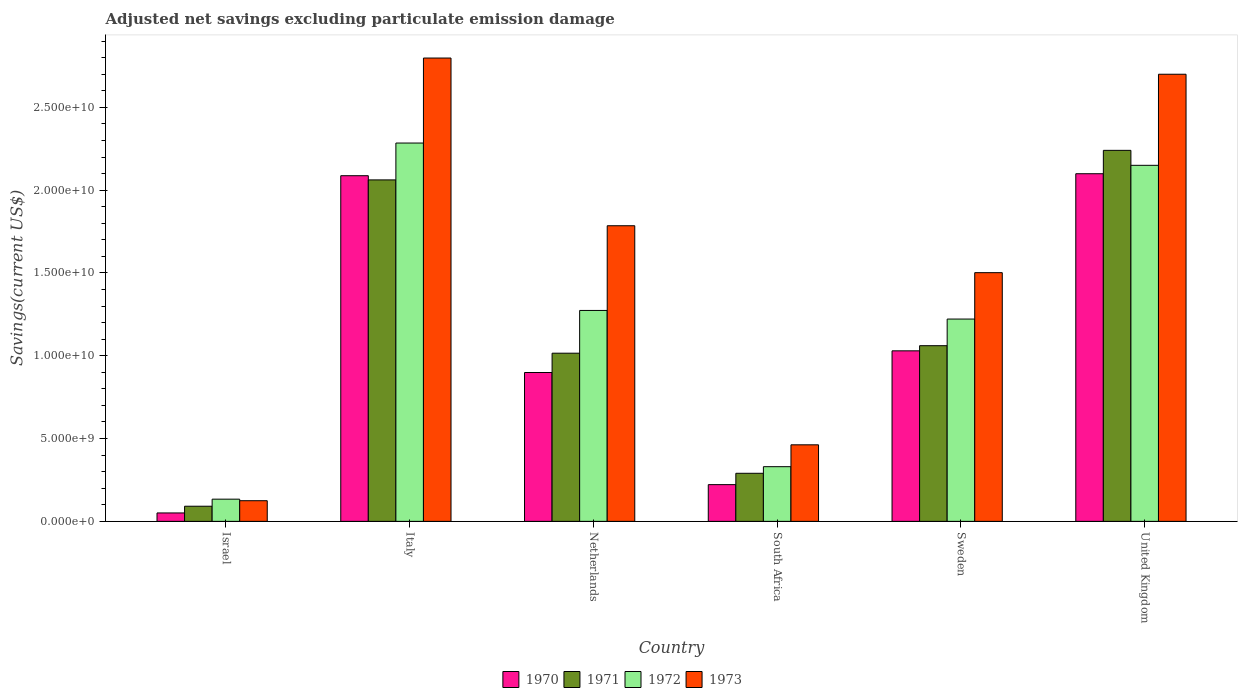How many groups of bars are there?
Offer a very short reply. 6. Are the number of bars per tick equal to the number of legend labels?
Give a very brief answer. Yes. How many bars are there on the 6th tick from the left?
Your answer should be compact. 4. How many bars are there on the 1st tick from the right?
Keep it short and to the point. 4. What is the label of the 3rd group of bars from the left?
Make the answer very short. Netherlands. What is the adjusted net savings in 1970 in Israel?
Give a very brief answer. 5.08e+08. Across all countries, what is the maximum adjusted net savings in 1973?
Provide a succinct answer. 2.80e+1. Across all countries, what is the minimum adjusted net savings in 1970?
Make the answer very short. 5.08e+08. In which country was the adjusted net savings in 1970 maximum?
Your response must be concise. United Kingdom. What is the total adjusted net savings in 1973 in the graph?
Your answer should be compact. 9.37e+1. What is the difference between the adjusted net savings in 1972 in Italy and that in Netherlands?
Give a very brief answer. 1.01e+1. What is the difference between the adjusted net savings in 1970 in United Kingdom and the adjusted net savings in 1972 in Italy?
Your response must be concise. -1.85e+09. What is the average adjusted net savings in 1970 per country?
Your answer should be compact. 1.06e+1. What is the difference between the adjusted net savings of/in 1971 and adjusted net savings of/in 1970 in Sweden?
Provide a succinct answer. 3.10e+08. What is the ratio of the adjusted net savings in 1970 in Netherlands to that in Sweden?
Your answer should be very brief. 0.87. Is the adjusted net savings in 1973 in Israel less than that in South Africa?
Your response must be concise. Yes. What is the difference between the highest and the second highest adjusted net savings in 1971?
Your response must be concise. -1.18e+1. What is the difference between the highest and the lowest adjusted net savings in 1972?
Your answer should be compact. 2.15e+1. In how many countries, is the adjusted net savings in 1972 greater than the average adjusted net savings in 1972 taken over all countries?
Ensure brevity in your answer.  3. What does the 4th bar from the right in Italy represents?
Offer a terse response. 1970. Is it the case that in every country, the sum of the adjusted net savings in 1970 and adjusted net savings in 1972 is greater than the adjusted net savings in 1971?
Your answer should be compact. Yes. How many bars are there?
Keep it short and to the point. 24. Does the graph contain grids?
Keep it short and to the point. No. Where does the legend appear in the graph?
Make the answer very short. Bottom center. What is the title of the graph?
Your response must be concise. Adjusted net savings excluding particulate emission damage. Does "1994" appear as one of the legend labels in the graph?
Ensure brevity in your answer.  No. What is the label or title of the Y-axis?
Your answer should be very brief. Savings(current US$). What is the Savings(current US$) of 1970 in Israel?
Offer a terse response. 5.08e+08. What is the Savings(current US$) of 1971 in Israel?
Offer a very short reply. 9.14e+08. What is the Savings(current US$) in 1972 in Israel?
Offer a terse response. 1.34e+09. What is the Savings(current US$) in 1973 in Israel?
Provide a short and direct response. 1.25e+09. What is the Savings(current US$) in 1970 in Italy?
Your response must be concise. 2.09e+1. What is the Savings(current US$) of 1971 in Italy?
Your answer should be compact. 2.06e+1. What is the Savings(current US$) of 1972 in Italy?
Offer a terse response. 2.28e+1. What is the Savings(current US$) of 1973 in Italy?
Your response must be concise. 2.80e+1. What is the Savings(current US$) in 1970 in Netherlands?
Your answer should be compact. 8.99e+09. What is the Savings(current US$) in 1971 in Netherlands?
Give a very brief answer. 1.02e+1. What is the Savings(current US$) of 1972 in Netherlands?
Keep it short and to the point. 1.27e+1. What is the Savings(current US$) in 1973 in Netherlands?
Provide a short and direct response. 1.79e+1. What is the Savings(current US$) in 1970 in South Africa?
Your response must be concise. 2.22e+09. What is the Savings(current US$) of 1971 in South Africa?
Make the answer very short. 2.90e+09. What is the Savings(current US$) in 1972 in South Africa?
Give a very brief answer. 3.30e+09. What is the Savings(current US$) in 1973 in South Africa?
Your answer should be compact. 4.62e+09. What is the Savings(current US$) of 1970 in Sweden?
Give a very brief answer. 1.03e+1. What is the Savings(current US$) of 1971 in Sweden?
Provide a succinct answer. 1.06e+1. What is the Savings(current US$) of 1972 in Sweden?
Ensure brevity in your answer.  1.22e+1. What is the Savings(current US$) of 1973 in Sweden?
Offer a very short reply. 1.50e+1. What is the Savings(current US$) in 1970 in United Kingdom?
Provide a succinct answer. 2.10e+1. What is the Savings(current US$) in 1971 in United Kingdom?
Your response must be concise. 2.24e+1. What is the Savings(current US$) in 1972 in United Kingdom?
Give a very brief answer. 2.15e+1. What is the Savings(current US$) of 1973 in United Kingdom?
Your answer should be compact. 2.70e+1. Across all countries, what is the maximum Savings(current US$) of 1970?
Offer a terse response. 2.10e+1. Across all countries, what is the maximum Savings(current US$) in 1971?
Keep it short and to the point. 2.24e+1. Across all countries, what is the maximum Savings(current US$) in 1972?
Make the answer very short. 2.28e+1. Across all countries, what is the maximum Savings(current US$) of 1973?
Provide a short and direct response. 2.80e+1. Across all countries, what is the minimum Savings(current US$) of 1970?
Offer a very short reply. 5.08e+08. Across all countries, what is the minimum Savings(current US$) of 1971?
Give a very brief answer. 9.14e+08. Across all countries, what is the minimum Savings(current US$) in 1972?
Make the answer very short. 1.34e+09. Across all countries, what is the minimum Savings(current US$) in 1973?
Your answer should be very brief. 1.25e+09. What is the total Savings(current US$) of 1970 in the graph?
Your answer should be compact. 6.39e+1. What is the total Savings(current US$) in 1971 in the graph?
Offer a terse response. 6.76e+1. What is the total Savings(current US$) in 1972 in the graph?
Your answer should be compact. 7.39e+1. What is the total Savings(current US$) in 1973 in the graph?
Make the answer very short. 9.37e+1. What is the difference between the Savings(current US$) of 1970 in Israel and that in Italy?
Keep it short and to the point. -2.04e+1. What is the difference between the Savings(current US$) in 1971 in Israel and that in Italy?
Your answer should be very brief. -1.97e+1. What is the difference between the Savings(current US$) of 1972 in Israel and that in Italy?
Make the answer very short. -2.15e+1. What is the difference between the Savings(current US$) in 1973 in Israel and that in Italy?
Provide a succinct answer. -2.67e+1. What is the difference between the Savings(current US$) in 1970 in Israel and that in Netherlands?
Provide a succinct answer. -8.48e+09. What is the difference between the Savings(current US$) in 1971 in Israel and that in Netherlands?
Your answer should be very brief. -9.24e+09. What is the difference between the Savings(current US$) of 1972 in Israel and that in Netherlands?
Offer a very short reply. -1.14e+1. What is the difference between the Savings(current US$) in 1973 in Israel and that in Netherlands?
Make the answer very short. -1.66e+1. What is the difference between the Savings(current US$) of 1970 in Israel and that in South Africa?
Your answer should be compact. -1.71e+09. What is the difference between the Savings(current US$) of 1971 in Israel and that in South Africa?
Make the answer very short. -1.99e+09. What is the difference between the Savings(current US$) of 1972 in Israel and that in South Africa?
Offer a terse response. -1.96e+09. What is the difference between the Savings(current US$) of 1973 in Israel and that in South Africa?
Keep it short and to the point. -3.38e+09. What is the difference between the Savings(current US$) of 1970 in Israel and that in Sweden?
Your answer should be very brief. -9.79e+09. What is the difference between the Savings(current US$) of 1971 in Israel and that in Sweden?
Your response must be concise. -9.69e+09. What is the difference between the Savings(current US$) of 1972 in Israel and that in Sweden?
Give a very brief answer. -1.09e+1. What is the difference between the Savings(current US$) of 1973 in Israel and that in Sweden?
Make the answer very short. -1.38e+1. What is the difference between the Savings(current US$) in 1970 in Israel and that in United Kingdom?
Provide a succinct answer. -2.05e+1. What is the difference between the Savings(current US$) of 1971 in Israel and that in United Kingdom?
Offer a very short reply. -2.15e+1. What is the difference between the Savings(current US$) in 1972 in Israel and that in United Kingdom?
Make the answer very short. -2.02e+1. What is the difference between the Savings(current US$) in 1973 in Israel and that in United Kingdom?
Offer a very short reply. -2.58e+1. What is the difference between the Savings(current US$) in 1970 in Italy and that in Netherlands?
Provide a short and direct response. 1.19e+1. What is the difference between the Savings(current US$) of 1971 in Italy and that in Netherlands?
Ensure brevity in your answer.  1.05e+1. What is the difference between the Savings(current US$) of 1972 in Italy and that in Netherlands?
Offer a terse response. 1.01e+1. What is the difference between the Savings(current US$) in 1973 in Italy and that in Netherlands?
Offer a terse response. 1.01e+1. What is the difference between the Savings(current US$) of 1970 in Italy and that in South Africa?
Your answer should be very brief. 1.87e+1. What is the difference between the Savings(current US$) in 1971 in Italy and that in South Africa?
Offer a very short reply. 1.77e+1. What is the difference between the Savings(current US$) in 1972 in Italy and that in South Africa?
Provide a succinct answer. 1.95e+1. What is the difference between the Savings(current US$) in 1973 in Italy and that in South Africa?
Provide a short and direct response. 2.34e+1. What is the difference between the Savings(current US$) of 1970 in Italy and that in Sweden?
Ensure brevity in your answer.  1.06e+1. What is the difference between the Savings(current US$) in 1971 in Italy and that in Sweden?
Your answer should be compact. 1.00e+1. What is the difference between the Savings(current US$) in 1972 in Italy and that in Sweden?
Your answer should be very brief. 1.06e+1. What is the difference between the Savings(current US$) of 1973 in Italy and that in Sweden?
Your answer should be compact. 1.30e+1. What is the difference between the Savings(current US$) in 1970 in Italy and that in United Kingdom?
Provide a short and direct response. -1.20e+08. What is the difference between the Savings(current US$) of 1971 in Italy and that in United Kingdom?
Give a very brief answer. -1.78e+09. What is the difference between the Savings(current US$) of 1972 in Italy and that in United Kingdom?
Keep it short and to the point. 1.34e+09. What is the difference between the Savings(current US$) in 1973 in Italy and that in United Kingdom?
Offer a very short reply. 9.78e+08. What is the difference between the Savings(current US$) of 1970 in Netherlands and that in South Africa?
Provide a short and direct response. 6.77e+09. What is the difference between the Savings(current US$) of 1971 in Netherlands and that in South Africa?
Your answer should be compact. 7.25e+09. What is the difference between the Savings(current US$) of 1972 in Netherlands and that in South Africa?
Your response must be concise. 9.43e+09. What is the difference between the Savings(current US$) in 1973 in Netherlands and that in South Africa?
Offer a terse response. 1.32e+1. What is the difference between the Savings(current US$) in 1970 in Netherlands and that in Sweden?
Offer a very short reply. -1.31e+09. What is the difference between the Savings(current US$) of 1971 in Netherlands and that in Sweden?
Provide a short and direct response. -4.54e+08. What is the difference between the Savings(current US$) of 1972 in Netherlands and that in Sweden?
Your answer should be very brief. 5.20e+08. What is the difference between the Savings(current US$) in 1973 in Netherlands and that in Sweden?
Make the answer very short. 2.83e+09. What is the difference between the Savings(current US$) in 1970 in Netherlands and that in United Kingdom?
Make the answer very short. -1.20e+1. What is the difference between the Savings(current US$) in 1971 in Netherlands and that in United Kingdom?
Ensure brevity in your answer.  -1.22e+1. What is the difference between the Savings(current US$) in 1972 in Netherlands and that in United Kingdom?
Your response must be concise. -8.76e+09. What is the difference between the Savings(current US$) of 1973 in Netherlands and that in United Kingdom?
Provide a short and direct response. -9.15e+09. What is the difference between the Savings(current US$) of 1970 in South Africa and that in Sweden?
Give a very brief answer. -8.08e+09. What is the difference between the Savings(current US$) in 1971 in South Africa and that in Sweden?
Keep it short and to the point. -7.70e+09. What is the difference between the Savings(current US$) of 1972 in South Africa and that in Sweden?
Your answer should be compact. -8.91e+09. What is the difference between the Savings(current US$) of 1973 in South Africa and that in Sweden?
Your answer should be compact. -1.04e+1. What is the difference between the Savings(current US$) of 1970 in South Africa and that in United Kingdom?
Provide a succinct answer. -1.88e+1. What is the difference between the Savings(current US$) in 1971 in South Africa and that in United Kingdom?
Keep it short and to the point. -1.95e+1. What is the difference between the Savings(current US$) in 1972 in South Africa and that in United Kingdom?
Your answer should be very brief. -1.82e+1. What is the difference between the Savings(current US$) of 1973 in South Africa and that in United Kingdom?
Ensure brevity in your answer.  -2.24e+1. What is the difference between the Savings(current US$) in 1970 in Sweden and that in United Kingdom?
Give a very brief answer. -1.07e+1. What is the difference between the Savings(current US$) in 1971 in Sweden and that in United Kingdom?
Offer a very short reply. -1.18e+1. What is the difference between the Savings(current US$) of 1972 in Sweden and that in United Kingdom?
Make the answer very short. -9.28e+09. What is the difference between the Savings(current US$) of 1973 in Sweden and that in United Kingdom?
Your answer should be very brief. -1.20e+1. What is the difference between the Savings(current US$) of 1970 in Israel and the Savings(current US$) of 1971 in Italy?
Offer a very short reply. -2.01e+1. What is the difference between the Savings(current US$) of 1970 in Israel and the Savings(current US$) of 1972 in Italy?
Your response must be concise. -2.23e+1. What is the difference between the Savings(current US$) in 1970 in Israel and the Savings(current US$) in 1973 in Italy?
Your response must be concise. -2.75e+1. What is the difference between the Savings(current US$) in 1971 in Israel and the Savings(current US$) in 1972 in Italy?
Offer a terse response. -2.19e+1. What is the difference between the Savings(current US$) in 1971 in Israel and the Savings(current US$) in 1973 in Italy?
Your answer should be compact. -2.71e+1. What is the difference between the Savings(current US$) in 1972 in Israel and the Savings(current US$) in 1973 in Italy?
Your response must be concise. -2.66e+1. What is the difference between the Savings(current US$) in 1970 in Israel and the Savings(current US$) in 1971 in Netherlands?
Provide a succinct answer. -9.65e+09. What is the difference between the Savings(current US$) in 1970 in Israel and the Savings(current US$) in 1972 in Netherlands?
Provide a succinct answer. -1.22e+1. What is the difference between the Savings(current US$) in 1970 in Israel and the Savings(current US$) in 1973 in Netherlands?
Your answer should be very brief. -1.73e+1. What is the difference between the Savings(current US$) of 1971 in Israel and the Savings(current US$) of 1972 in Netherlands?
Your answer should be very brief. -1.18e+1. What is the difference between the Savings(current US$) of 1971 in Israel and the Savings(current US$) of 1973 in Netherlands?
Keep it short and to the point. -1.69e+1. What is the difference between the Savings(current US$) of 1972 in Israel and the Savings(current US$) of 1973 in Netherlands?
Your answer should be compact. -1.65e+1. What is the difference between the Savings(current US$) of 1970 in Israel and the Savings(current US$) of 1971 in South Africa?
Your answer should be compact. -2.39e+09. What is the difference between the Savings(current US$) in 1970 in Israel and the Savings(current US$) in 1972 in South Africa?
Offer a terse response. -2.79e+09. What is the difference between the Savings(current US$) of 1970 in Israel and the Savings(current US$) of 1973 in South Africa?
Ensure brevity in your answer.  -4.11e+09. What is the difference between the Savings(current US$) in 1971 in Israel and the Savings(current US$) in 1972 in South Africa?
Provide a succinct answer. -2.39e+09. What is the difference between the Savings(current US$) of 1971 in Israel and the Savings(current US$) of 1973 in South Africa?
Provide a succinct answer. -3.71e+09. What is the difference between the Savings(current US$) of 1972 in Israel and the Savings(current US$) of 1973 in South Africa?
Your answer should be compact. -3.28e+09. What is the difference between the Savings(current US$) of 1970 in Israel and the Savings(current US$) of 1971 in Sweden?
Provide a short and direct response. -1.01e+1. What is the difference between the Savings(current US$) of 1970 in Israel and the Savings(current US$) of 1972 in Sweden?
Offer a very short reply. -1.17e+1. What is the difference between the Savings(current US$) in 1970 in Israel and the Savings(current US$) in 1973 in Sweden?
Your answer should be very brief. -1.45e+1. What is the difference between the Savings(current US$) of 1971 in Israel and the Savings(current US$) of 1972 in Sweden?
Ensure brevity in your answer.  -1.13e+1. What is the difference between the Savings(current US$) of 1971 in Israel and the Savings(current US$) of 1973 in Sweden?
Provide a succinct answer. -1.41e+1. What is the difference between the Savings(current US$) in 1972 in Israel and the Savings(current US$) in 1973 in Sweden?
Your answer should be compact. -1.37e+1. What is the difference between the Savings(current US$) of 1970 in Israel and the Savings(current US$) of 1971 in United Kingdom?
Your answer should be very brief. -2.19e+1. What is the difference between the Savings(current US$) of 1970 in Israel and the Savings(current US$) of 1972 in United Kingdom?
Provide a short and direct response. -2.10e+1. What is the difference between the Savings(current US$) of 1970 in Israel and the Savings(current US$) of 1973 in United Kingdom?
Provide a succinct answer. -2.65e+1. What is the difference between the Savings(current US$) in 1971 in Israel and the Savings(current US$) in 1972 in United Kingdom?
Keep it short and to the point. -2.06e+1. What is the difference between the Savings(current US$) of 1971 in Israel and the Savings(current US$) of 1973 in United Kingdom?
Make the answer very short. -2.61e+1. What is the difference between the Savings(current US$) of 1972 in Israel and the Savings(current US$) of 1973 in United Kingdom?
Provide a succinct answer. -2.57e+1. What is the difference between the Savings(current US$) of 1970 in Italy and the Savings(current US$) of 1971 in Netherlands?
Provide a short and direct response. 1.07e+1. What is the difference between the Savings(current US$) of 1970 in Italy and the Savings(current US$) of 1972 in Netherlands?
Keep it short and to the point. 8.14e+09. What is the difference between the Savings(current US$) in 1970 in Italy and the Savings(current US$) in 1973 in Netherlands?
Keep it short and to the point. 3.02e+09. What is the difference between the Savings(current US$) of 1971 in Italy and the Savings(current US$) of 1972 in Netherlands?
Ensure brevity in your answer.  7.88e+09. What is the difference between the Savings(current US$) in 1971 in Italy and the Savings(current US$) in 1973 in Netherlands?
Make the answer very short. 2.77e+09. What is the difference between the Savings(current US$) of 1972 in Italy and the Savings(current US$) of 1973 in Netherlands?
Offer a terse response. 4.99e+09. What is the difference between the Savings(current US$) of 1970 in Italy and the Savings(current US$) of 1971 in South Africa?
Your answer should be compact. 1.80e+1. What is the difference between the Savings(current US$) in 1970 in Italy and the Savings(current US$) in 1972 in South Africa?
Ensure brevity in your answer.  1.76e+1. What is the difference between the Savings(current US$) of 1970 in Italy and the Savings(current US$) of 1973 in South Africa?
Offer a very short reply. 1.62e+1. What is the difference between the Savings(current US$) in 1971 in Italy and the Savings(current US$) in 1972 in South Africa?
Keep it short and to the point. 1.73e+1. What is the difference between the Savings(current US$) in 1971 in Italy and the Savings(current US$) in 1973 in South Africa?
Your answer should be very brief. 1.60e+1. What is the difference between the Savings(current US$) of 1972 in Italy and the Savings(current US$) of 1973 in South Africa?
Your answer should be very brief. 1.82e+1. What is the difference between the Savings(current US$) of 1970 in Italy and the Savings(current US$) of 1971 in Sweden?
Offer a terse response. 1.03e+1. What is the difference between the Savings(current US$) of 1970 in Italy and the Savings(current US$) of 1972 in Sweden?
Offer a very short reply. 8.66e+09. What is the difference between the Savings(current US$) in 1970 in Italy and the Savings(current US$) in 1973 in Sweden?
Give a very brief answer. 5.85e+09. What is the difference between the Savings(current US$) of 1971 in Italy and the Savings(current US$) of 1972 in Sweden?
Provide a succinct answer. 8.40e+09. What is the difference between the Savings(current US$) of 1971 in Italy and the Savings(current US$) of 1973 in Sweden?
Keep it short and to the point. 5.60e+09. What is the difference between the Savings(current US$) of 1972 in Italy and the Savings(current US$) of 1973 in Sweden?
Your answer should be compact. 7.83e+09. What is the difference between the Savings(current US$) of 1970 in Italy and the Savings(current US$) of 1971 in United Kingdom?
Ensure brevity in your answer.  -1.53e+09. What is the difference between the Savings(current US$) of 1970 in Italy and the Savings(current US$) of 1972 in United Kingdom?
Offer a very short reply. -6.28e+08. What is the difference between the Savings(current US$) in 1970 in Italy and the Savings(current US$) in 1973 in United Kingdom?
Ensure brevity in your answer.  -6.13e+09. What is the difference between the Savings(current US$) of 1971 in Italy and the Savings(current US$) of 1972 in United Kingdom?
Make the answer very short. -8.80e+08. What is the difference between the Savings(current US$) in 1971 in Italy and the Savings(current US$) in 1973 in United Kingdom?
Offer a terse response. -6.38e+09. What is the difference between the Savings(current US$) of 1972 in Italy and the Savings(current US$) of 1973 in United Kingdom?
Give a very brief answer. -4.15e+09. What is the difference between the Savings(current US$) in 1970 in Netherlands and the Savings(current US$) in 1971 in South Africa?
Give a very brief answer. 6.09e+09. What is the difference between the Savings(current US$) in 1970 in Netherlands and the Savings(current US$) in 1972 in South Africa?
Offer a very short reply. 5.69e+09. What is the difference between the Savings(current US$) of 1970 in Netherlands and the Savings(current US$) of 1973 in South Africa?
Offer a very short reply. 4.37e+09. What is the difference between the Savings(current US$) in 1971 in Netherlands and the Savings(current US$) in 1972 in South Africa?
Make the answer very short. 6.85e+09. What is the difference between the Savings(current US$) in 1971 in Netherlands and the Savings(current US$) in 1973 in South Africa?
Offer a terse response. 5.53e+09. What is the difference between the Savings(current US$) of 1972 in Netherlands and the Savings(current US$) of 1973 in South Africa?
Keep it short and to the point. 8.11e+09. What is the difference between the Savings(current US$) of 1970 in Netherlands and the Savings(current US$) of 1971 in Sweden?
Ensure brevity in your answer.  -1.62e+09. What is the difference between the Savings(current US$) of 1970 in Netherlands and the Savings(current US$) of 1972 in Sweden?
Provide a succinct answer. -3.23e+09. What is the difference between the Savings(current US$) in 1970 in Netherlands and the Savings(current US$) in 1973 in Sweden?
Give a very brief answer. -6.03e+09. What is the difference between the Savings(current US$) in 1971 in Netherlands and the Savings(current US$) in 1972 in Sweden?
Your response must be concise. -2.06e+09. What is the difference between the Savings(current US$) of 1971 in Netherlands and the Savings(current US$) of 1973 in Sweden?
Give a very brief answer. -4.86e+09. What is the difference between the Savings(current US$) in 1972 in Netherlands and the Savings(current US$) in 1973 in Sweden?
Give a very brief answer. -2.28e+09. What is the difference between the Savings(current US$) in 1970 in Netherlands and the Savings(current US$) in 1971 in United Kingdom?
Make the answer very short. -1.34e+1. What is the difference between the Savings(current US$) of 1970 in Netherlands and the Savings(current US$) of 1972 in United Kingdom?
Your answer should be compact. -1.25e+1. What is the difference between the Savings(current US$) in 1970 in Netherlands and the Savings(current US$) in 1973 in United Kingdom?
Your response must be concise. -1.80e+1. What is the difference between the Savings(current US$) of 1971 in Netherlands and the Savings(current US$) of 1972 in United Kingdom?
Your answer should be very brief. -1.13e+1. What is the difference between the Savings(current US$) in 1971 in Netherlands and the Savings(current US$) in 1973 in United Kingdom?
Offer a terse response. -1.68e+1. What is the difference between the Savings(current US$) in 1972 in Netherlands and the Savings(current US$) in 1973 in United Kingdom?
Provide a succinct answer. -1.43e+1. What is the difference between the Savings(current US$) in 1970 in South Africa and the Savings(current US$) in 1971 in Sweden?
Your response must be concise. -8.39e+09. What is the difference between the Savings(current US$) of 1970 in South Africa and the Savings(current US$) of 1972 in Sweden?
Provide a short and direct response. -1.00e+1. What is the difference between the Savings(current US$) in 1970 in South Africa and the Savings(current US$) in 1973 in Sweden?
Provide a succinct answer. -1.28e+1. What is the difference between the Savings(current US$) in 1971 in South Africa and the Savings(current US$) in 1972 in Sweden?
Keep it short and to the point. -9.31e+09. What is the difference between the Savings(current US$) in 1971 in South Africa and the Savings(current US$) in 1973 in Sweden?
Your answer should be compact. -1.21e+1. What is the difference between the Savings(current US$) in 1972 in South Africa and the Savings(current US$) in 1973 in Sweden?
Provide a short and direct response. -1.17e+1. What is the difference between the Savings(current US$) in 1970 in South Africa and the Savings(current US$) in 1971 in United Kingdom?
Your answer should be compact. -2.02e+1. What is the difference between the Savings(current US$) in 1970 in South Africa and the Savings(current US$) in 1972 in United Kingdom?
Make the answer very short. -1.93e+1. What is the difference between the Savings(current US$) in 1970 in South Africa and the Savings(current US$) in 1973 in United Kingdom?
Your answer should be very brief. -2.48e+1. What is the difference between the Savings(current US$) in 1971 in South Africa and the Savings(current US$) in 1972 in United Kingdom?
Your answer should be compact. -1.86e+1. What is the difference between the Savings(current US$) of 1971 in South Africa and the Savings(current US$) of 1973 in United Kingdom?
Provide a short and direct response. -2.41e+1. What is the difference between the Savings(current US$) of 1972 in South Africa and the Savings(current US$) of 1973 in United Kingdom?
Make the answer very short. -2.37e+1. What is the difference between the Savings(current US$) of 1970 in Sweden and the Savings(current US$) of 1971 in United Kingdom?
Ensure brevity in your answer.  -1.21e+1. What is the difference between the Savings(current US$) of 1970 in Sweden and the Savings(current US$) of 1972 in United Kingdom?
Offer a terse response. -1.12e+1. What is the difference between the Savings(current US$) in 1970 in Sweden and the Savings(current US$) in 1973 in United Kingdom?
Offer a terse response. -1.67e+1. What is the difference between the Savings(current US$) of 1971 in Sweden and the Savings(current US$) of 1972 in United Kingdom?
Your answer should be compact. -1.09e+1. What is the difference between the Savings(current US$) of 1971 in Sweden and the Savings(current US$) of 1973 in United Kingdom?
Keep it short and to the point. -1.64e+1. What is the difference between the Savings(current US$) of 1972 in Sweden and the Savings(current US$) of 1973 in United Kingdom?
Provide a short and direct response. -1.48e+1. What is the average Savings(current US$) of 1970 per country?
Provide a short and direct response. 1.06e+1. What is the average Savings(current US$) in 1971 per country?
Provide a short and direct response. 1.13e+1. What is the average Savings(current US$) in 1972 per country?
Your answer should be compact. 1.23e+1. What is the average Savings(current US$) of 1973 per country?
Provide a short and direct response. 1.56e+1. What is the difference between the Savings(current US$) in 1970 and Savings(current US$) in 1971 in Israel?
Your response must be concise. -4.06e+08. What is the difference between the Savings(current US$) in 1970 and Savings(current US$) in 1972 in Israel?
Provide a short and direct response. -8.33e+08. What is the difference between the Savings(current US$) of 1970 and Savings(current US$) of 1973 in Israel?
Provide a succinct answer. -7.39e+08. What is the difference between the Savings(current US$) of 1971 and Savings(current US$) of 1972 in Israel?
Offer a terse response. -4.27e+08. What is the difference between the Savings(current US$) of 1971 and Savings(current US$) of 1973 in Israel?
Offer a very short reply. -3.33e+08. What is the difference between the Savings(current US$) of 1972 and Savings(current US$) of 1973 in Israel?
Your answer should be compact. 9.40e+07. What is the difference between the Savings(current US$) of 1970 and Savings(current US$) of 1971 in Italy?
Your response must be concise. 2.53e+08. What is the difference between the Savings(current US$) in 1970 and Savings(current US$) in 1972 in Italy?
Offer a very short reply. -1.97e+09. What is the difference between the Savings(current US$) of 1970 and Savings(current US$) of 1973 in Italy?
Provide a succinct answer. -7.11e+09. What is the difference between the Savings(current US$) in 1971 and Savings(current US$) in 1972 in Italy?
Provide a short and direct response. -2.23e+09. What is the difference between the Savings(current US$) of 1971 and Savings(current US$) of 1973 in Italy?
Your answer should be compact. -7.36e+09. What is the difference between the Savings(current US$) in 1972 and Savings(current US$) in 1973 in Italy?
Give a very brief answer. -5.13e+09. What is the difference between the Savings(current US$) of 1970 and Savings(current US$) of 1971 in Netherlands?
Ensure brevity in your answer.  -1.17e+09. What is the difference between the Savings(current US$) of 1970 and Savings(current US$) of 1972 in Netherlands?
Keep it short and to the point. -3.75e+09. What is the difference between the Savings(current US$) of 1970 and Savings(current US$) of 1973 in Netherlands?
Offer a terse response. -8.86e+09. What is the difference between the Savings(current US$) of 1971 and Savings(current US$) of 1972 in Netherlands?
Give a very brief answer. -2.58e+09. What is the difference between the Savings(current US$) of 1971 and Savings(current US$) of 1973 in Netherlands?
Keep it short and to the point. -7.70e+09. What is the difference between the Savings(current US$) of 1972 and Savings(current US$) of 1973 in Netherlands?
Keep it short and to the point. -5.11e+09. What is the difference between the Savings(current US$) in 1970 and Savings(current US$) in 1971 in South Africa?
Your answer should be compact. -6.85e+08. What is the difference between the Savings(current US$) of 1970 and Savings(current US$) of 1972 in South Africa?
Provide a short and direct response. -1.08e+09. What is the difference between the Savings(current US$) in 1970 and Savings(current US$) in 1973 in South Africa?
Your answer should be very brief. -2.40e+09. What is the difference between the Savings(current US$) of 1971 and Savings(current US$) of 1972 in South Africa?
Provide a succinct answer. -4.00e+08. What is the difference between the Savings(current US$) in 1971 and Savings(current US$) in 1973 in South Africa?
Your answer should be compact. -1.72e+09. What is the difference between the Savings(current US$) in 1972 and Savings(current US$) in 1973 in South Africa?
Provide a succinct answer. -1.32e+09. What is the difference between the Savings(current US$) of 1970 and Savings(current US$) of 1971 in Sweden?
Offer a terse response. -3.10e+08. What is the difference between the Savings(current US$) in 1970 and Savings(current US$) in 1972 in Sweden?
Give a very brief answer. -1.92e+09. What is the difference between the Savings(current US$) of 1970 and Savings(current US$) of 1973 in Sweden?
Provide a succinct answer. -4.72e+09. What is the difference between the Savings(current US$) in 1971 and Savings(current US$) in 1972 in Sweden?
Your answer should be very brief. -1.61e+09. What is the difference between the Savings(current US$) of 1971 and Savings(current US$) of 1973 in Sweden?
Ensure brevity in your answer.  -4.41e+09. What is the difference between the Savings(current US$) of 1972 and Savings(current US$) of 1973 in Sweden?
Your answer should be compact. -2.80e+09. What is the difference between the Savings(current US$) of 1970 and Savings(current US$) of 1971 in United Kingdom?
Give a very brief answer. -1.41e+09. What is the difference between the Savings(current US$) in 1970 and Savings(current US$) in 1972 in United Kingdom?
Provide a succinct answer. -5.08e+08. What is the difference between the Savings(current US$) in 1970 and Savings(current US$) in 1973 in United Kingdom?
Your answer should be compact. -6.01e+09. What is the difference between the Savings(current US$) in 1971 and Savings(current US$) in 1972 in United Kingdom?
Ensure brevity in your answer.  9.03e+08. What is the difference between the Savings(current US$) of 1971 and Savings(current US$) of 1973 in United Kingdom?
Provide a succinct answer. -4.60e+09. What is the difference between the Savings(current US$) of 1972 and Savings(current US$) of 1973 in United Kingdom?
Your answer should be very brief. -5.50e+09. What is the ratio of the Savings(current US$) in 1970 in Israel to that in Italy?
Provide a succinct answer. 0.02. What is the ratio of the Savings(current US$) of 1971 in Israel to that in Italy?
Give a very brief answer. 0.04. What is the ratio of the Savings(current US$) in 1972 in Israel to that in Italy?
Your answer should be compact. 0.06. What is the ratio of the Savings(current US$) in 1973 in Israel to that in Italy?
Your answer should be compact. 0.04. What is the ratio of the Savings(current US$) in 1970 in Israel to that in Netherlands?
Provide a short and direct response. 0.06. What is the ratio of the Savings(current US$) of 1971 in Israel to that in Netherlands?
Make the answer very short. 0.09. What is the ratio of the Savings(current US$) of 1972 in Israel to that in Netherlands?
Your answer should be very brief. 0.11. What is the ratio of the Savings(current US$) of 1973 in Israel to that in Netherlands?
Keep it short and to the point. 0.07. What is the ratio of the Savings(current US$) of 1970 in Israel to that in South Africa?
Keep it short and to the point. 0.23. What is the ratio of the Savings(current US$) of 1971 in Israel to that in South Africa?
Offer a terse response. 0.32. What is the ratio of the Savings(current US$) of 1972 in Israel to that in South Africa?
Provide a short and direct response. 0.41. What is the ratio of the Savings(current US$) in 1973 in Israel to that in South Africa?
Your answer should be very brief. 0.27. What is the ratio of the Savings(current US$) in 1970 in Israel to that in Sweden?
Keep it short and to the point. 0.05. What is the ratio of the Savings(current US$) in 1971 in Israel to that in Sweden?
Your answer should be very brief. 0.09. What is the ratio of the Savings(current US$) of 1972 in Israel to that in Sweden?
Your answer should be compact. 0.11. What is the ratio of the Savings(current US$) in 1973 in Israel to that in Sweden?
Keep it short and to the point. 0.08. What is the ratio of the Savings(current US$) in 1970 in Israel to that in United Kingdom?
Give a very brief answer. 0.02. What is the ratio of the Savings(current US$) of 1971 in Israel to that in United Kingdom?
Provide a short and direct response. 0.04. What is the ratio of the Savings(current US$) of 1972 in Israel to that in United Kingdom?
Give a very brief answer. 0.06. What is the ratio of the Savings(current US$) of 1973 in Israel to that in United Kingdom?
Give a very brief answer. 0.05. What is the ratio of the Savings(current US$) in 1970 in Italy to that in Netherlands?
Provide a succinct answer. 2.32. What is the ratio of the Savings(current US$) of 1971 in Italy to that in Netherlands?
Provide a short and direct response. 2.03. What is the ratio of the Savings(current US$) of 1972 in Italy to that in Netherlands?
Provide a succinct answer. 1.79. What is the ratio of the Savings(current US$) of 1973 in Italy to that in Netherlands?
Make the answer very short. 1.57. What is the ratio of the Savings(current US$) of 1970 in Italy to that in South Africa?
Keep it short and to the point. 9.41. What is the ratio of the Savings(current US$) of 1971 in Italy to that in South Africa?
Make the answer very short. 7.1. What is the ratio of the Savings(current US$) in 1972 in Italy to that in South Africa?
Your answer should be very brief. 6.92. What is the ratio of the Savings(current US$) in 1973 in Italy to that in South Africa?
Make the answer very short. 6.05. What is the ratio of the Savings(current US$) in 1970 in Italy to that in Sweden?
Make the answer very short. 2.03. What is the ratio of the Savings(current US$) in 1971 in Italy to that in Sweden?
Your answer should be very brief. 1.94. What is the ratio of the Savings(current US$) in 1972 in Italy to that in Sweden?
Give a very brief answer. 1.87. What is the ratio of the Savings(current US$) of 1973 in Italy to that in Sweden?
Ensure brevity in your answer.  1.86. What is the ratio of the Savings(current US$) in 1971 in Italy to that in United Kingdom?
Offer a very short reply. 0.92. What is the ratio of the Savings(current US$) of 1972 in Italy to that in United Kingdom?
Provide a short and direct response. 1.06. What is the ratio of the Savings(current US$) of 1973 in Italy to that in United Kingdom?
Make the answer very short. 1.04. What is the ratio of the Savings(current US$) in 1970 in Netherlands to that in South Africa?
Ensure brevity in your answer.  4.05. What is the ratio of the Savings(current US$) in 1971 in Netherlands to that in South Africa?
Offer a terse response. 3.5. What is the ratio of the Savings(current US$) of 1972 in Netherlands to that in South Africa?
Keep it short and to the point. 3.86. What is the ratio of the Savings(current US$) of 1973 in Netherlands to that in South Africa?
Your response must be concise. 3.86. What is the ratio of the Savings(current US$) in 1970 in Netherlands to that in Sweden?
Make the answer very short. 0.87. What is the ratio of the Savings(current US$) in 1971 in Netherlands to that in Sweden?
Provide a succinct answer. 0.96. What is the ratio of the Savings(current US$) in 1972 in Netherlands to that in Sweden?
Your answer should be compact. 1.04. What is the ratio of the Savings(current US$) in 1973 in Netherlands to that in Sweden?
Give a very brief answer. 1.19. What is the ratio of the Savings(current US$) in 1970 in Netherlands to that in United Kingdom?
Offer a very short reply. 0.43. What is the ratio of the Savings(current US$) in 1971 in Netherlands to that in United Kingdom?
Your response must be concise. 0.45. What is the ratio of the Savings(current US$) of 1972 in Netherlands to that in United Kingdom?
Provide a short and direct response. 0.59. What is the ratio of the Savings(current US$) in 1973 in Netherlands to that in United Kingdom?
Provide a succinct answer. 0.66. What is the ratio of the Savings(current US$) in 1970 in South Africa to that in Sweden?
Offer a terse response. 0.22. What is the ratio of the Savings(current US$) in 1971 in South Africa to that in Sweden?
Make the answer very short. 0.27. What is the ratio of the Savings(current US$) of 1972 in South Africa to that in Sweden?
Provide a succinct answer. 0.27. What is the ratio of the Savings(current US$) of 1973 in South Africa to that in Sweden?
Keep it short and to the point. 0.31. What is the ratio of the Savings(current US$) of 1970 in South Africa to that in United Kingdom?
Keep it short and to the point. 0.11. What is the ratio of the Savings(current US$) of 1971 in South Africa to that in United Kingdom?
Provide a succinct answer. 0.13. What is the ratio of the Savings(current US$) in 1972 in South Africa to that in United Kingdom?
Make the answer very short. 0.15. What is the ratio of the Savings(current US$) of 1973 in South Africa to that in United Kingdom?
Give a very brief answer. 0.17. What is the ratio of the Savings(current US$) in 1970 in Sweden to that in United Kingdom?
Offer a terse response. 0.49. What is the ratio of the Savings(current US$) of 1971 in Sweden to that in United Kingdom?
Ensure brevity in your answer.  0.47. What is the ratio of the Savings(current US$) of 1972 in Sweden to that in United Kingdom?
Make the answer very short. 0.57. What is the ratio of the Savings(current US$) of 1973 in Sweden to that in United Kingdom?
Your answer should be very brief. 0.56. What is the difference between the highest and the second highest Savings(current US$) in 1970?
Give a very brief answer. 1.20e+08. What is the difference between the highest and the second highest Savings(current US$) in 1971?
Give a very brief answer. 1.78e+09. What is the difference between the highest and the second highest Savings(current US$) of 1972?
Offer a terse response. 1.34e+09. What is the difference between the highest and the second highest Savings(current US$) in 1973?
Ensure brevity in your answer.  9.78e+08. What is the difference between the highest and the lowest Savings(current US$) in 1970?
Make the answer very short. 2.05e+1. What is the difference between the highest and the lowest Savings(current US$) in 1971?
Your answer should be very brief. 2.15e+1. What is the difference between the highest and the lowest Savings(current US$) of 1972?
Offer a very short reply. 2.15e+1. What is the difference between the highest and the lowest Savings(current US$) of 1973?
Ensure brevity in your answer.  2.67e+1. 